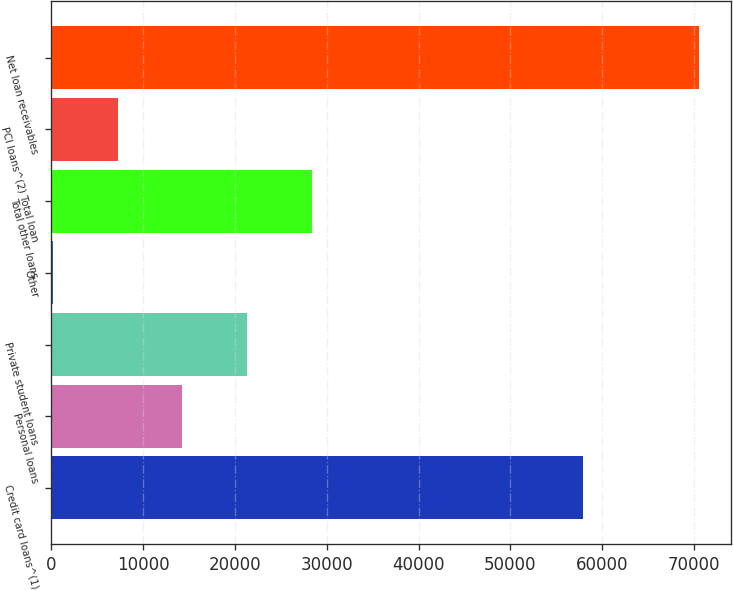Convert chart to OTSL. <chart><loc_0><loc_0><loc_500><loc_500><bar_chart><fcel>Credit card loans^(1)<fcel>Personal loans<fcel>Private student loans<fcel>Other<fcel>Total other loans<fcel>PCI loans^(2) Total loan<fcel>Net loan receivables<nl><fcel>57896<fcel>14292<fcel>21320<fcel>236<fcel>28348<fcel>7264<fcel>70516<nl></chart> 